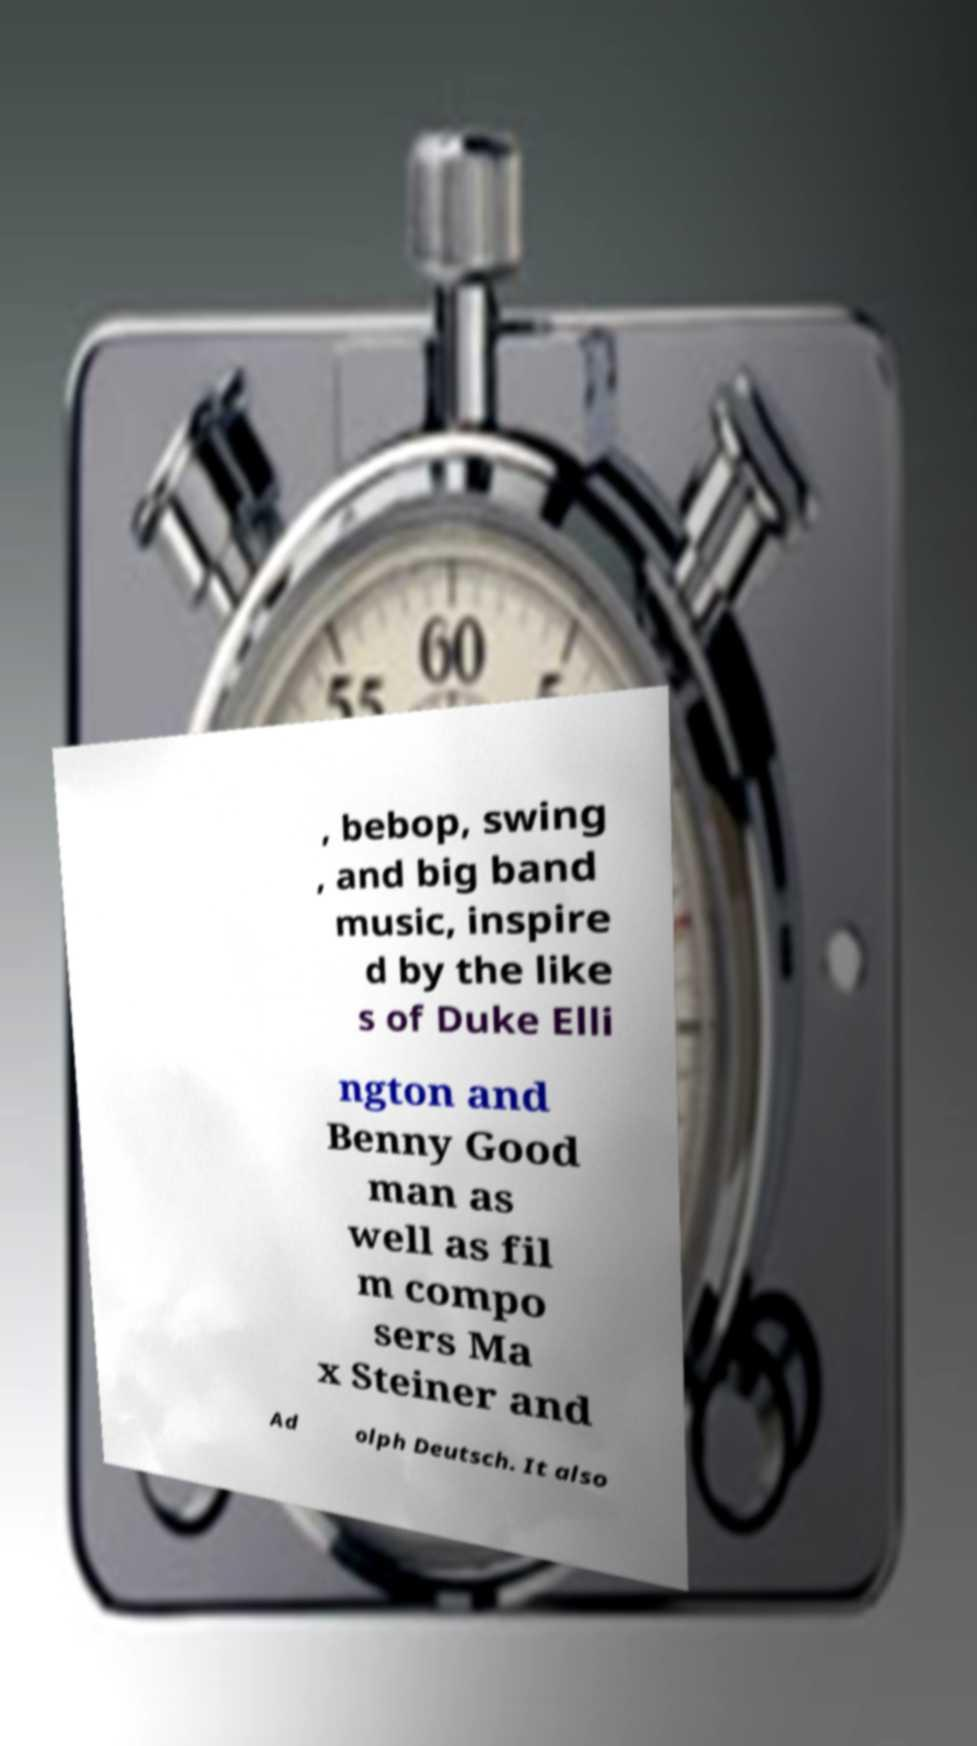I need the written content from this picture converted into text. Can you do that? , bebop, swing , and big band music, inspire d by the like s of Duke Elli ngton and Benny Good man as well as fil m compo sers Ma x Steiner and Ad olph Deutsch. It also 